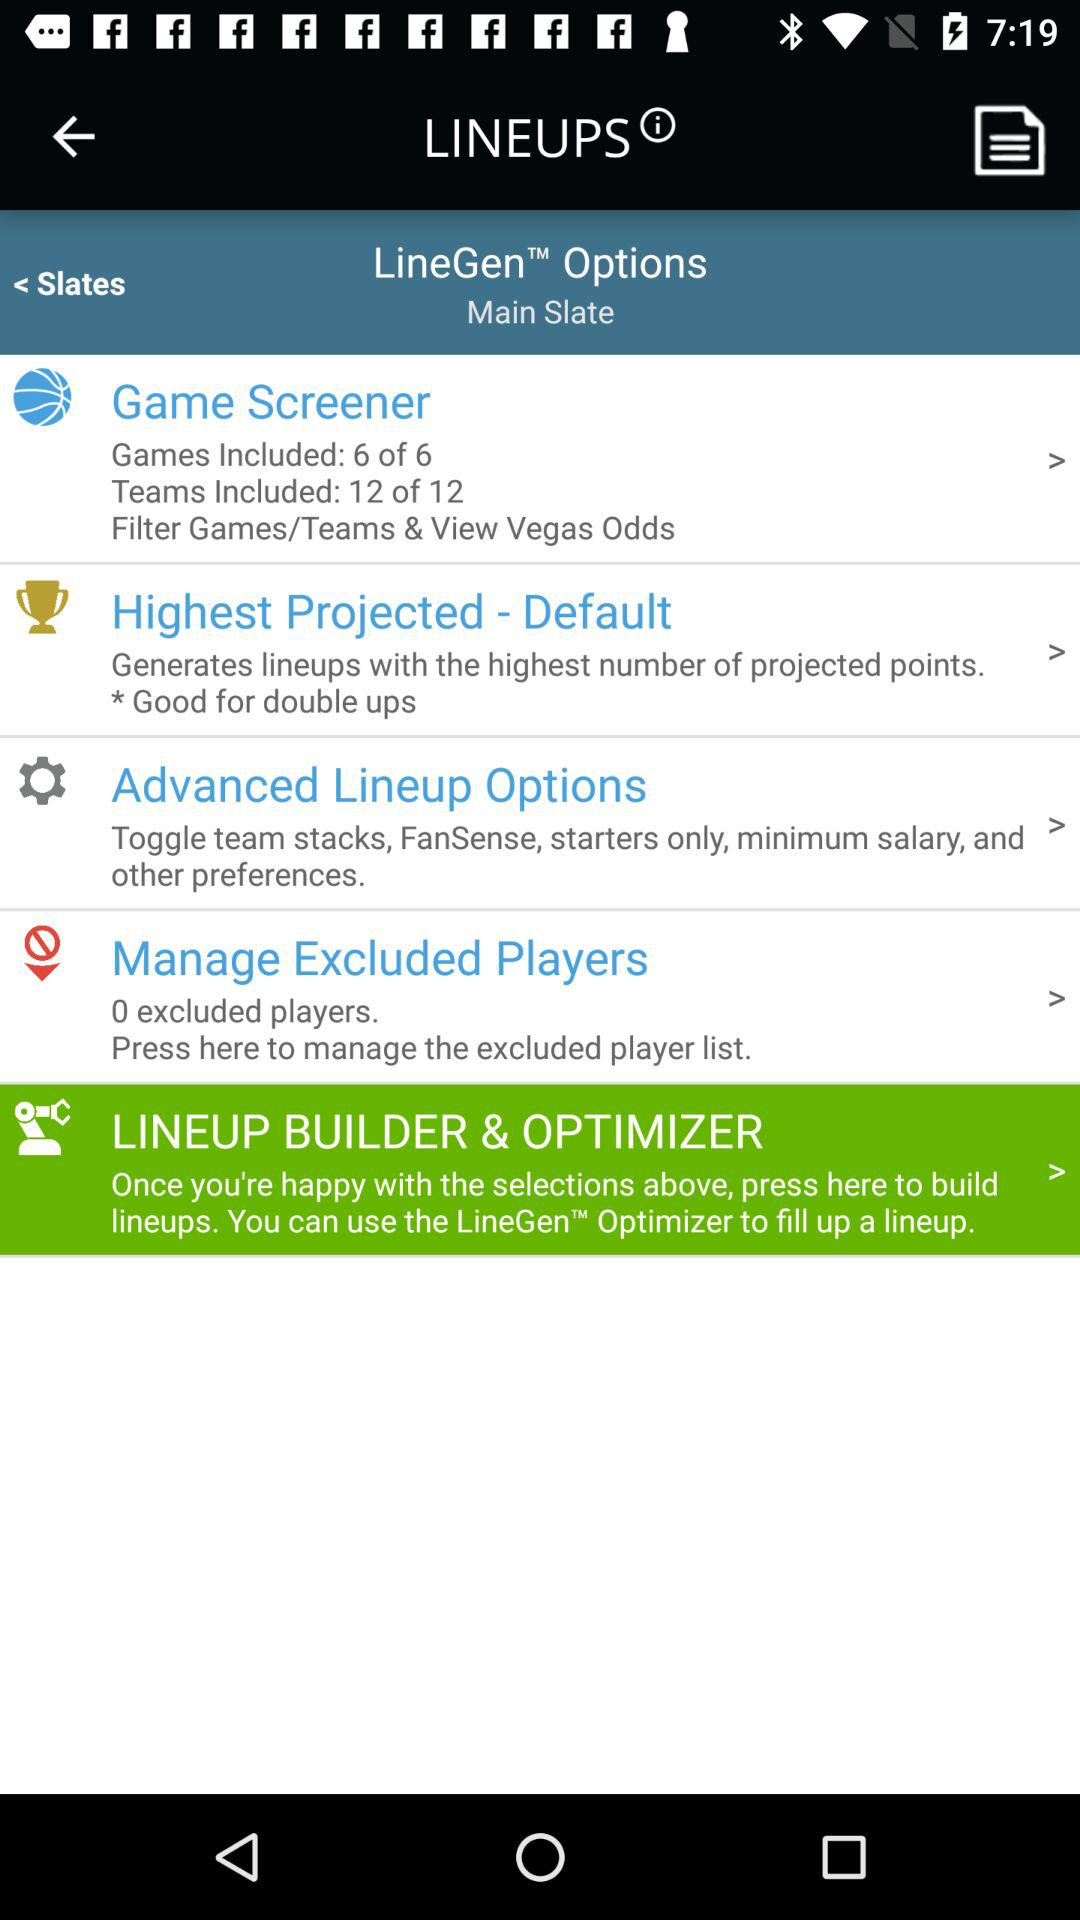What number of games are included? The number of games included is 6. 